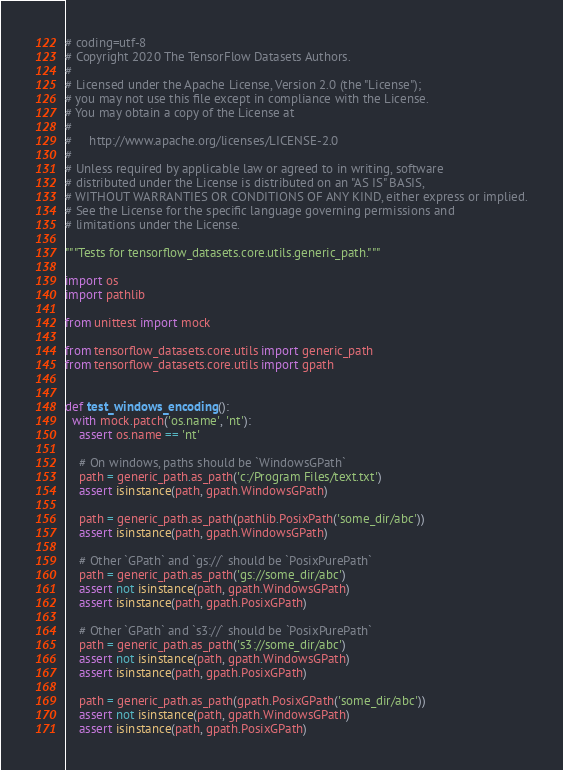<code> <loc_0><loc_0><loc_500><loc_500><_Python_># coding=utf-8
# Copyright 2020 The TensorFlow Datasets Authors.
#
# Licensed under the Apache License, Version 2.0 (the "License");
# you may not use this file except in compliance with the License.
# You may obtain a copy of the License at
#
#     http://www.apache.org/licenses/LICENSE-2.0
#
# Unless required by applicable law or agreed to in writing, software
# distributed under the License is distributed on an "AS IS" BASIS,
# WITHOUT WARRANTIES OR CONDITIONS OF ANY KIND, either express or implied.
# See the License for the specific language governing permissions and
# limitations under the License.

"""Tests for tensorflow_datasets.core.utils.generic_path."""

import os
import pathlib

from unittest import mock

from tensorflow_datasets.core.utils import generic_path
from tensorflow_datasets.core.utils import gpath


def test_windows_encoding():
  with mock.patch('os.name', 'nt'):
    assert os.name == 'nt'

    # On windows, paths should be `WindowsGPath`
    path = generic_path.as_path('c:/Program Files/text.txt')
    assert isinstance(path, gpath.WindowsGPath)

    path = generic_path.as_path(pathlib.PosixPath('some_dir/abc'))
    assert isinstance(path, gpath.WindowsGPath)

    # Other `GPath` and `gs://` should be `PosixPurePath`
    path = generic_path.as_path('gs://some_dir/abc')
    assert not isinstance(path, gpath.WindowsGPath)
    assert isinstance(path, gpath.PosixGPath)

    # Other `GPath` and `s3://` should be `PosixPurePath`
    path = generic_path.as_path('s3://some_dir/abc')
    assert not isinstance(path, gpath.WindowsGPath)
    assert isinstance(path, gpath.PosixGPath)

    path = generic_path.as_path(gpath.PosixGPath('some_dir/abc'))
    assert not isinstance(path, gpath.WindowsGPath)
    assert isinstance(path, gpath.PosixGPath)
</code> 